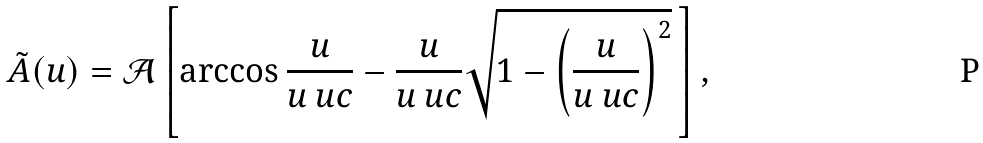Convert formula to latex. <formula><loc_0><loc_0><loc_500><loc_500>\tilde { A } ( u ) = \mathcal { A } \left [ \arccos \frac { u } { u _ { \ } u c } - \frac { u } { u _ { \ } u c } \sqrt { 1 - \left ( \frac { u } { u _ { \ } u c } \right ) ^ { 2 } } \, \right ] ,</formula> 